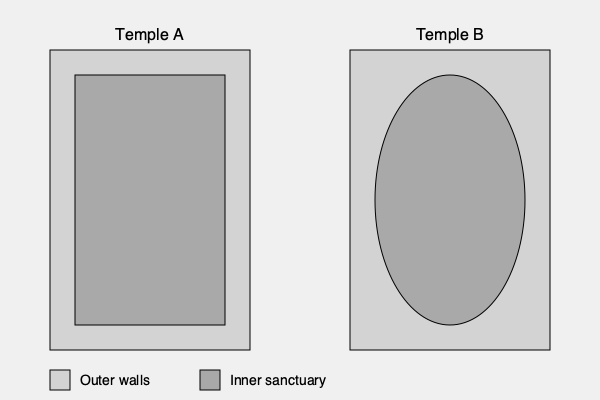Analyze the aerial view diagrams of Temple A and Temple B. Which architectural feature distinguishes the inner sanctuary of Temple B from that of Temple A, and what historical or cultural significance might this difference represent? To answer this question, we need to carefully examine the aerial view diagrams and consider the historical and cultural implications of the architectural differences:

1. Temple A layout:
   - Rectangular outer walls
   - Rectangular inner sanctuary

2. Temple B layout:
   - Rectangular outer walls
   - Elliptical (or circular) inner sanctuary

3. Key difference:
   The inner sanctuary of Temple B is elliptical, while Temple A's is rectangular.

4. Historical and cultural significance:
   a) Rectangular layouts (Temple A):
      - Common in many ancient cultures (e.g., Egyptian, Greek, Roman)
      - Often associated with cosmic order, cardinal directions, and linear thinking
      - May represent a more structured, hierarchical approach to worship

   b) Circular or elliptical layouts (Temple B):
      - Found in various cultures, but less common (e.g., some Celtic, Native American, or Eastern traditions)
      - Often associated with cyclical time, unity, and holistic worldviews
      - May represent a more egalitarian or nature-centered approach to worship

   c) The coexistence of these two layouts might suggest:
      - Different periods of construction or cultural influences
      - Distinct philosophical or theological approaches within the same religious tradition
      - Possible fusion of two different cultural or religious traditions

5. Interpretation:
   The elliptical inner sanctuary of Temple B likely represents a departure from more conventional rectangular designs, possibly indicating:
   - Influence from a different cultural tradition
   - A shift in religious or philosophical thinking
   - An attempt to incorporate cosmic symbolism (e.g., sun, moon, or celestial movements)

This architectural difference provides valuable insight into the potential diversity of religious practices, cultural exchanges, or theological developments in the region where these temples were built.
Answer: Temple B has an elliptical inner sanctuary, potentially representing cyclical time concepts, unity, or nature-centered worship, in contrast to Temple A's rectangular layout. 